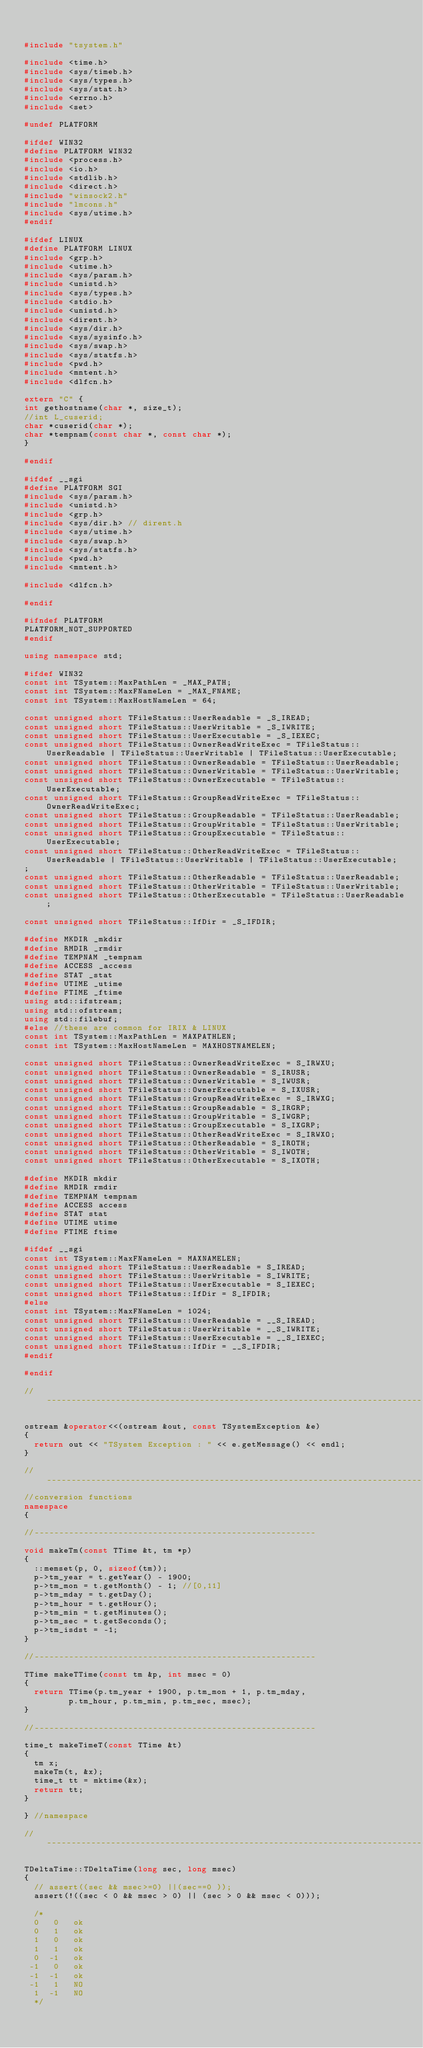<code> <loc_0><loc_0><loc_500><loc_500><_C++_>

#include "tsystem.h"

#include <time.h>
#include <sys/timeb.h>
#include <sys/types.h>
#include <sys/stat.h>
#include <errno.h>
#include <set>

#undef PLATFORM

#ifdef WIN32
#define PLATFORM WIN32
#include <process.h>
#include <io.h>
#include <stdlib.h>
#include <direct.h>
#include "winsock2.h"
#include "lmcons.h"
#include <sys/utime.h>
#endif

#ifdef LINUX
#define PLATFORM LINUX
#include <grp.h>
#include <utime.h>
#include <sys/param.h>
#include <unistd.h>
#include <sys/types.h>
#include <stdio.h>
#include <unistd.h>
#include <dirent.h>
#include <sys/dir.h>
#include <sys/sysinfo.h>
#include <sys/swap.h>
#include <sys/statfs.h>
#include <pwd.h>
#include <mntent.h>
#include <dlfcn.h>

extern "C" {
int gethostname(char *, size_t);
//int L_cuserid;
char *cuserid(char *);
char *tempnam(const char *, const char *);
}

#endif

#ifdef __sgi
#define PLATFORM SGI
#include <sys/param.h>
#include <unistd.h>
#include <grp.h>
#include <sys/dir.h> // dirent.h
#include <sys/utime.h>
#include <sys/swap.h>
#include <sys/statfs.h>
#include <pwd.h>
#include <mntent.h>

#include <dlfcn.h>

#endif

#ifndef PLATFORM
PLATFORM_NOT_SUPPORTED
#endif

using namespace std;

#ifdef WIN32
const int TSystem::MaxPathLen = _MAX_PATH;
const int TSystem::MaxFNameLen = _MAX_FNAME;
const int TSystem::MaxHostNameLen = 64;

const unsigned short TFileStatus::UserReadable = _S_IREAD;
const unsigned short TFileStatus::UserWritable = _S_IWRITE;
const unsigned short TFileStatus::UserExecutable = _S_IEXEC;
const unsigned short TFileStatus::OwnerReadWriteExec = TFileStatus::UserReadable | TFileStatus::UserWritable | TFileStatus::UserExecutable;
const unsigned short TFileStatus::OwnerReadable = TFileStatus::UserReadable;
const unsigned short TFileStatus::OwnerWritable = TFileStatus::UserWritable;
const unsigned short TFileStatus::OwnerExecutable = TFileStatus::UserExecutable;
const unsigned short TFileStatus::GroupReadWriteExec = TFileStatus::OwnerReadWriteExec;
const unsigned short TFileStatus::GroupReadable = TFileStatus::UserReadable;
const unsigned short TFileStatus::GroupWritable = TFileStatus::UserWritable;
const unsigned short TFileStatus::GroupExecutable = TFileStatus::UserExecutable;
const unsigned short TFileStatus::OtherReadWriteExec = TFileStatus::UserReadable | TFileStatus::UserWritable | TFileStatus::UserExecutable;
;
const unsigned short TFileStatus::OtherReadable = TFileStatus::UserReadable;
const unsigned short TFileStatus::OtherWritable = TFileStatus::UserWritable;
const unsigned short TFileStatus::OtherExecutable = TFileStatus::UserReadable;

const unsigned short TFileStatus::IfDir = _S_IFDIR;

#define MKDIR _mkdir
#define RMDIR _rmdir
#define TEMPNAM _tempnam
#define ACCESS _access
#define STAT _stat
#define UTIME _utime
#define FTIME _ftime
using std::ifstream;
using std::ofstream;
using std::filebuf;
#else //these are common for IRIX & LINUX
const int TSystem::MaxPathLen = MAXPATHLEN;
const int TSystem::MaxHostNameLen = MAXHOSTNAMELEN;

const unsigned short TFileStatus::OwnerReadWriteExec = S_IRWXU;
const unsigned short TFileStatus::OwnerReadable = S_IRUSR;
const unsigned short TFileStatus::OwnerWritable = S_IWUSR;
const unsigned short TFileStatus::OwnerExecutable = S_IXUSR;
const unsigned short TFileStatus::GroupReadWriteExec = S_IRWXG;
const unsigned short TFileStatus::GroupReadable = S_IRGRP;
const unsigned short TFileStatus::GroupWritable = S_IWGRP;
const unsigned short TFileStatus::GroupExecutable = S_IXGRP;
const unsigned short TFileStatus::OtherReadWriteExec = S_IRWXO;
const unsigned short TFileStatus::OtherReadable = S_IROTH;
const unsigned short TFileStatus::OtherWritable = S_IWOTH;
const unsigned short TFileStatus::OtherExecutable = S_IXOTH;

#define MKDIR mkdir
#define RMDIR rmdir
#define TEMPNAM tempnam
#define ACCESS access
#define STAT stat
#define UTIME utime
#define FTIME ftime

#ifdef __sgi
const int TSystem::MaxFNameLen = MAXNAMELEN;
const unsigned short TFileStatus::UserReadable = S_IREAD;
const unsigned short TFileStatus::UserWritable = S_IWRITE;
const unsigned short TFileStatus::UserExecutable = S_IEXEC;
const unsigned short TFileStatus::IfDir = S_IFDIR;
#else
const int TSystem::MaxFNameLen = 1024;
const unsigned short TFileStatus::UserReadable = __S_IREAD;
const unsigned short TFileStatus::UserWritable = __S_IWRITE;
const unsigned short TFileStatus::UserExecutable = __S_IEXEC;
const unsigned short TFileStatus::IfDir = __S_IFDIR;
#endif

#endif

//-----------------------------------------------------------------------------------

ostream &operator<<(ostream &out, const TSystemException &e)
{
	return out << "TSystem Exception : " << e.getMessage() << endl;
}

//-----------------------------------------------------------------------------------
//conversion functions
namespace
{

//---------------------------------------------------------

void makeTm(const TTime &t, tm *p)
{
	::memset(p, 0, sizeof(tm));
	p->tm_year = t.getYear() - 1900;
	p->tm_mon = t.getMonth() - 1; //[0,11]
	p->tm_mday = t.getDay();
	p->tm_hour = t.getHour();
	p->tm_min = t.getMinutes();
	p->tm_sec = t.getSeconds();
	p->tm_isdst = -1;
}

//---------------------------------------------------------

TTime makeTTime(const tm &p, int msec = 0)
{
	return TTime(p.tm_year + 1900, p.tm_mon + 1, p.tm_mday,
				 p.tm_hour, p.tm_min, p.tm_sec, msec);
}

//---------------------------------------------------------

time_t makeTimeT(const TTime &t)
{
	tm x;
	makeTm(t, &x);
	time_t tt = mktime(&x);
	return tt;
}

} //namespace

//-----------------------------------------------------------------------------------

TDeltaTime::TDeltaTime(long sec, long msec)
{
	// assert((sec && msec>=0) ||(sec==0 ));
	assert(!((sec < 0 && msec > 0) || (sec > 0 && msec < 0)));

	/*
  0   0   ok
  0   1   ok
  1   0   ok
  1   1   ok
  0  -1   ok
 -1   0   ok
 -1  -1   ok
 -1   1   NO
  1  -1   NO
  */
</code> 